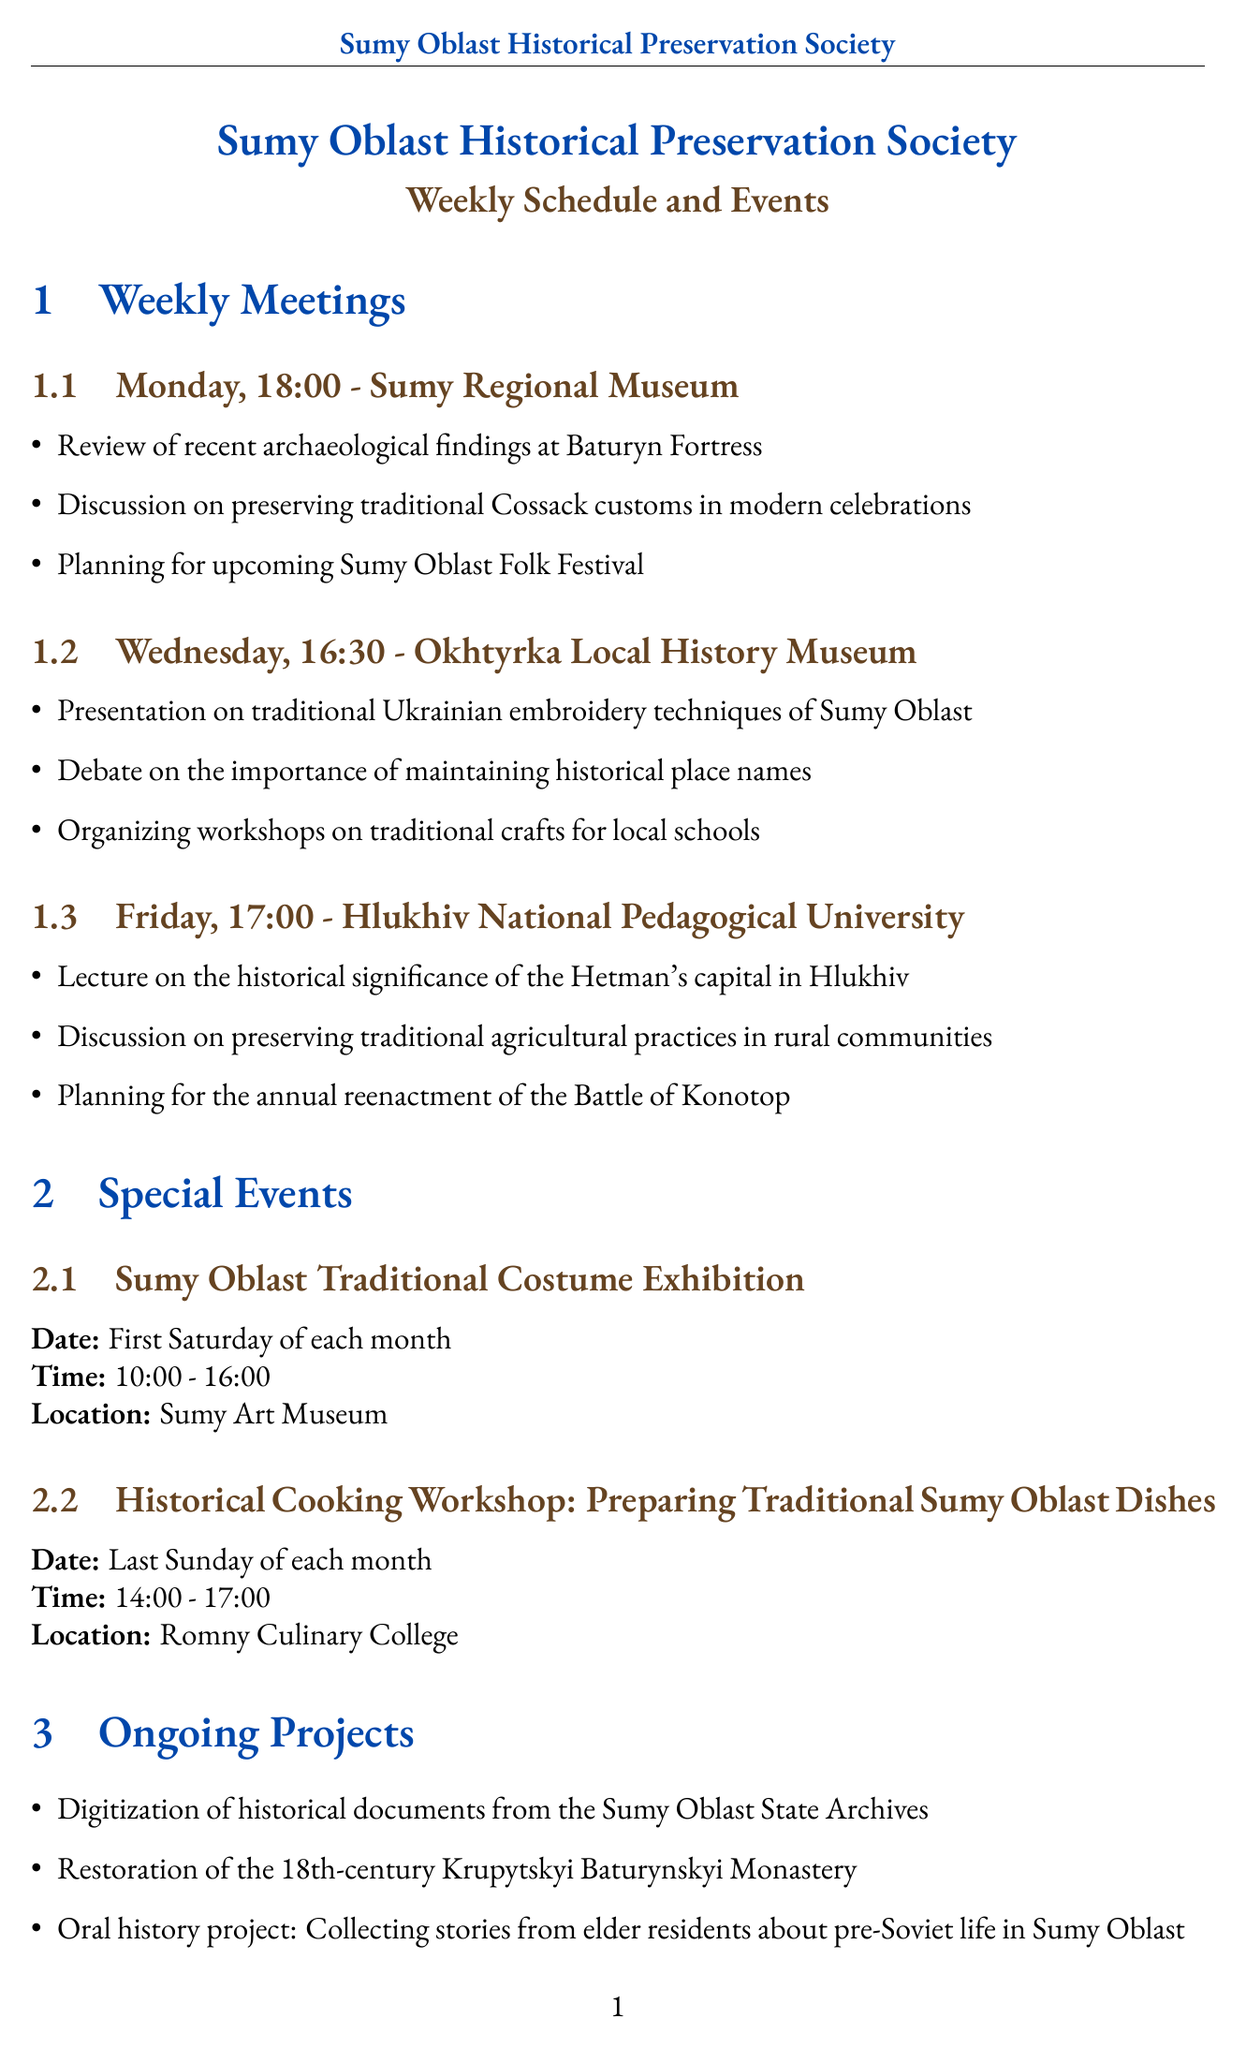What is the name of the society? The name of the society is mentioned at the beginning of the document in a bold format.
Answer: Sumy Oblast Historical Preservation Society What day is the Sumy Oblast Traditional Costume Exhibition held? The specific day for this exhibition is noted in the special events section of the document.
Answer: First Saturday of each month What time does the Monday meeting start? The time for the Monday meeting is given in the weekly meetings section.
Answer: 18:00 Which museum hosts the Wednesday meeting? The location of the Wednesday meeting is stated in the meeting schedule.
Answer: Okhtyrka Local History Museum What is one of the agenda items for the Friday meeting? The agenda item is listed under the Friday meeting details.
Answer: Lecture on the historical significance of the Hetman's capital in Hlukhiv What is the main focus of the presentation on Wednesday? The presentation's topic is clearly indicated in the Wednesday agenda.
Answer: Traditional Ukrainian embroidery techniques of Sumy Oblast How many ongoing projects are listed? The number of projects is counted in the ongoing projects section of the document.
Answer: 3 What is one of the collaboration partners mentioned? The collaboration partners are listed in a specific section of the document.
Answer: Ivan Bohun Sumy State University What type of workshop is scheduled for the last Sunday of each month? The workshop's focus is described in the special events section.
Answer: Historical Cooking Workshop What is the location of the Friday meeting? The location for the Friday meeting is specified in the meeting schedule.
Answer: Hlukhiv National Pedagogical University 